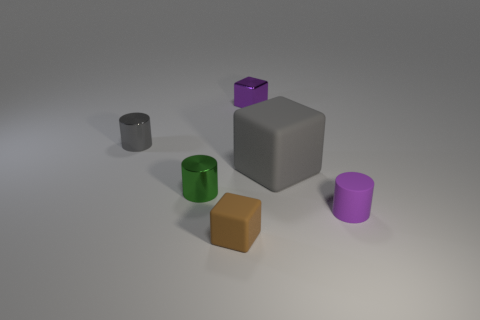There is a matte block that is in front of the rubber object that is on the right side of the gray matte thing; are there any tiny purple rubber objects that are in front of it?
Offer a very short reply. No. How many green metallic cylinders have the same size as the purple matte object?
Offer a terse response. 1. The block to the left of the small metal thing right of the brown matte cube is made of what material?
Your answer should be compact. Rubber. What is the shape of the tiny metallic thing in front of the large matte object on the left side of the tiny purple matte cylinder behind the small brown matte thing?
Make the answer very short. Cylinder. Does the small purple object that is left of the big gray object have the same shape as the tiny purple object in front of the small gray object?
Ensure brevity in your answer.  No. There is a gray thing that is the same material as the tiny green cylinder; what shape is it?
Make the answer very short. Cylinder. Is the size of the purple block the same as the brown cube?
Offer a terse response. Yes. How big is the purple rubber cylinder to the right of the gray object right of the tiny gray object?
Keep it short and to the point. Small. What shape is the other object that is the same color as the big matte thing?
Make the answer very short. Cylinder. How many balls are brown objects or blue matte things?
Make the answer very short. 0. 